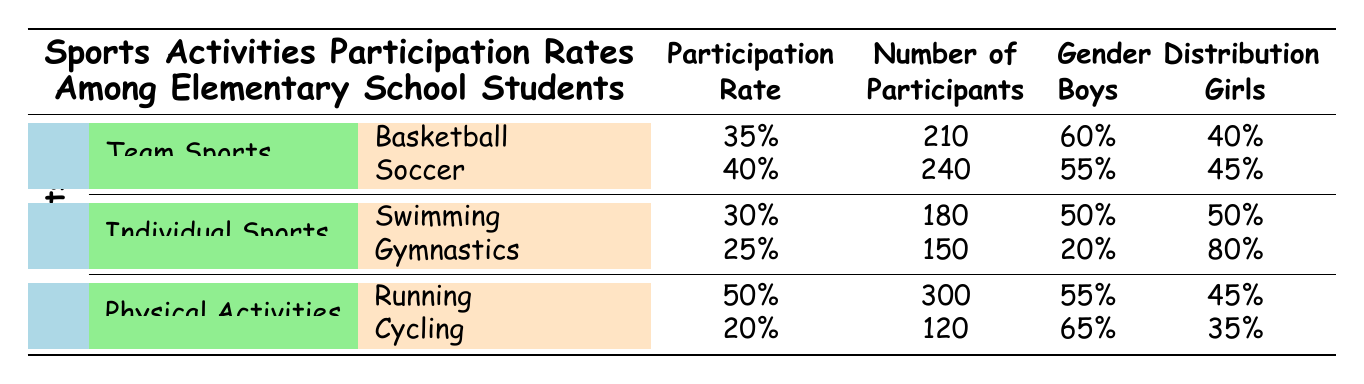What is the participation rate for basketball? The participation rate for basketball is directly listed in the table under Team Sports. It shows that the participation rate is 35%.
Answer: 35% How many participants are involved in soccer? Under the Team Sports section, the table indicates that there are 240 participants in soccer, which is directly stated.
Answer: 240 What is the gender distribution for gymnastics? The gender distribution for gymnastics is specified in the table: 20% of the participants are boys and 80% are girls.
Answer: Boys: 20%, Girls: 80% Which sport has the highest participation rate? To determine which sport has the highest participation rate, we need to compare the rates listed. The participation rates are: Basketball (35%), Soccer (40%), Swimming (30%), Gymnastics (25%), Running (50%), and Cycling (20%). The maximum rate is 50% for Running.
Answer: Running How many more participants are in soccer than in gymnastics? We find the number of participants in both sports: Soccer has 240 participants, and Gymnastics has 150 participants. The difference is calculated as 240 - 150 = 90.
Answer: 90 Is the participation rate for cycling higher than that for swimming? The participation rate for cycling is 20%, and for swimming, it is 30%. Comparing these, we find that 20% is not higher than 30%. Therefore, the statement is false.
Answer: No What is the average participation rate of individual sports? The participation rates for individual sports are Swimming (30%) and Gymnastics (25%). To find the average, we sum these rates: 30% + 25% = 55%, and then divide by 2 to get the average: 55% / 2 = 27.5%.
Answer: 27.5% Which sports have a participation rate of less than 30%? Looking at the table under the sports activities, Swimming has a participation rate of 30% and Gymnastics has a participation rate of 25%. Thus, only Gymnastics meets the criteria with a rate less than 30%.
Answer: Gymnastics What percentage of boys participate in running compared to girls? The gender distribution for running shows that 55% of participants are boys and 45% are girls. This indicates that a higher percentage of boys participate.
Answer: Yes, more boys participate 